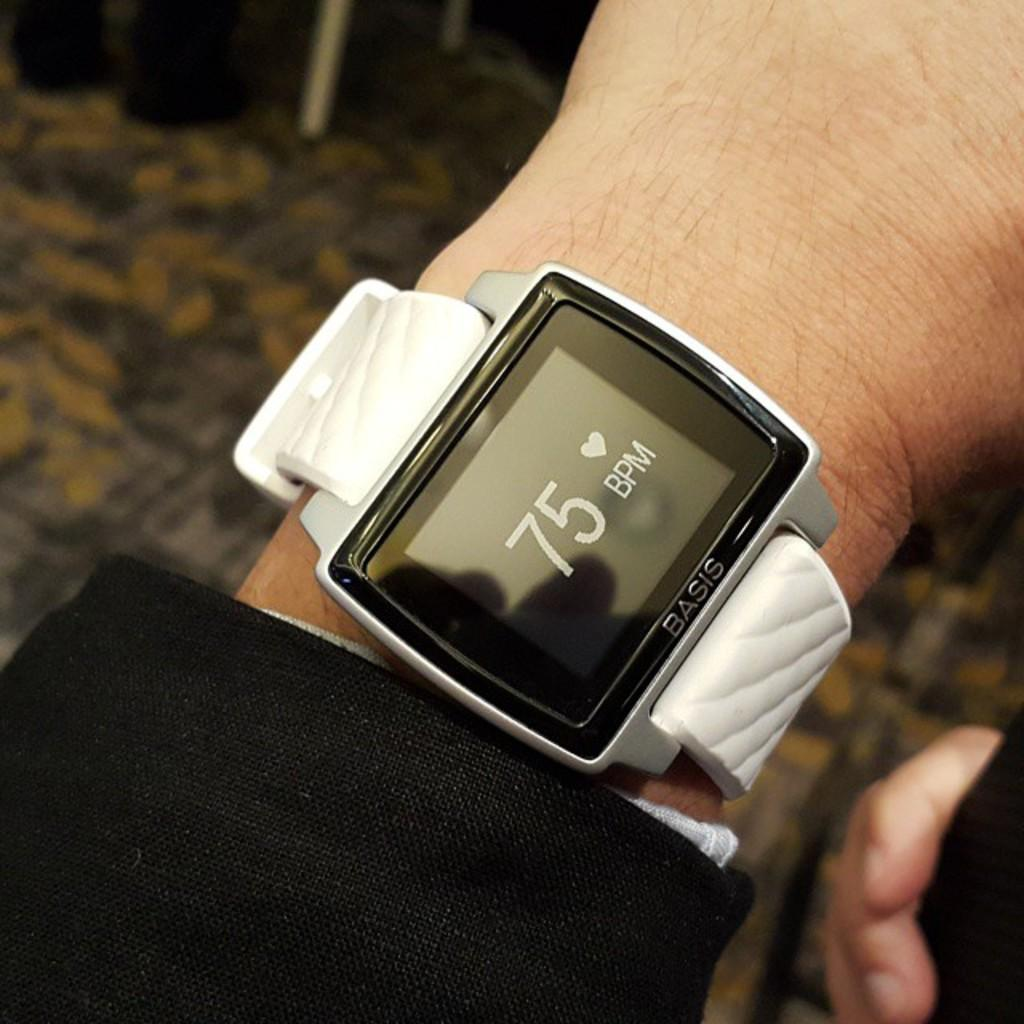<image>
Relay a brief, clear account of the picture shown. a person wearing a watch that shows 75 bpm 